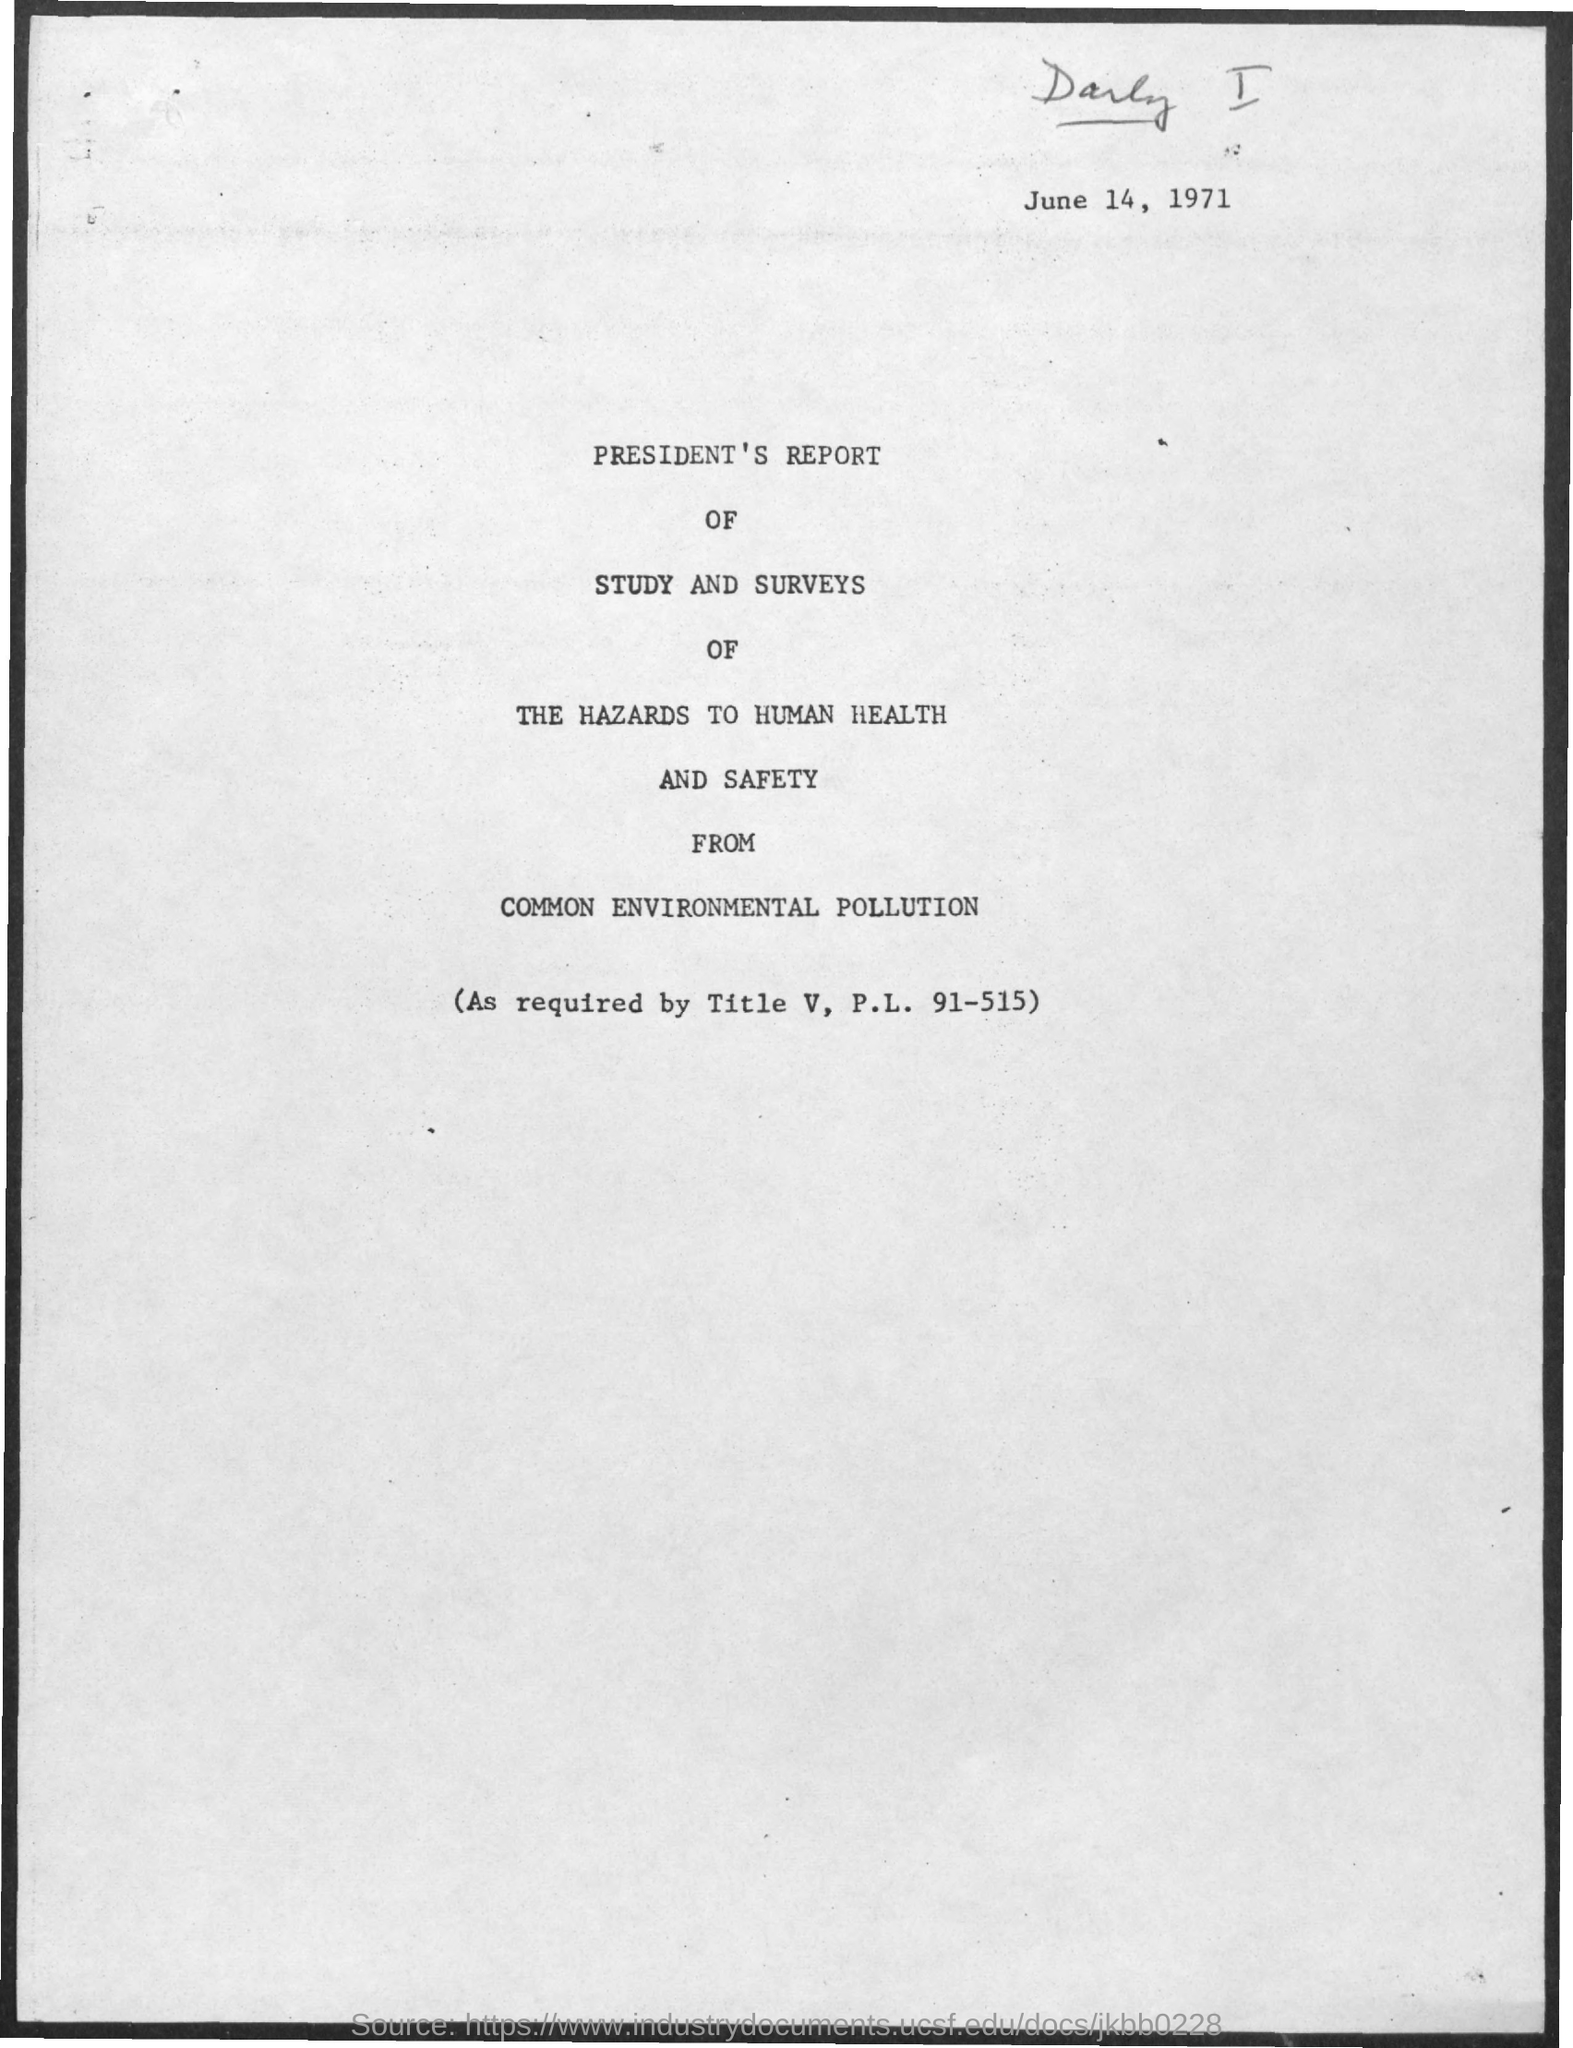What is the date on the document?
Offer a terse response. June 14, 1971. As required by?
Keep it short and to the point. Title V, P.L. 91-515. 